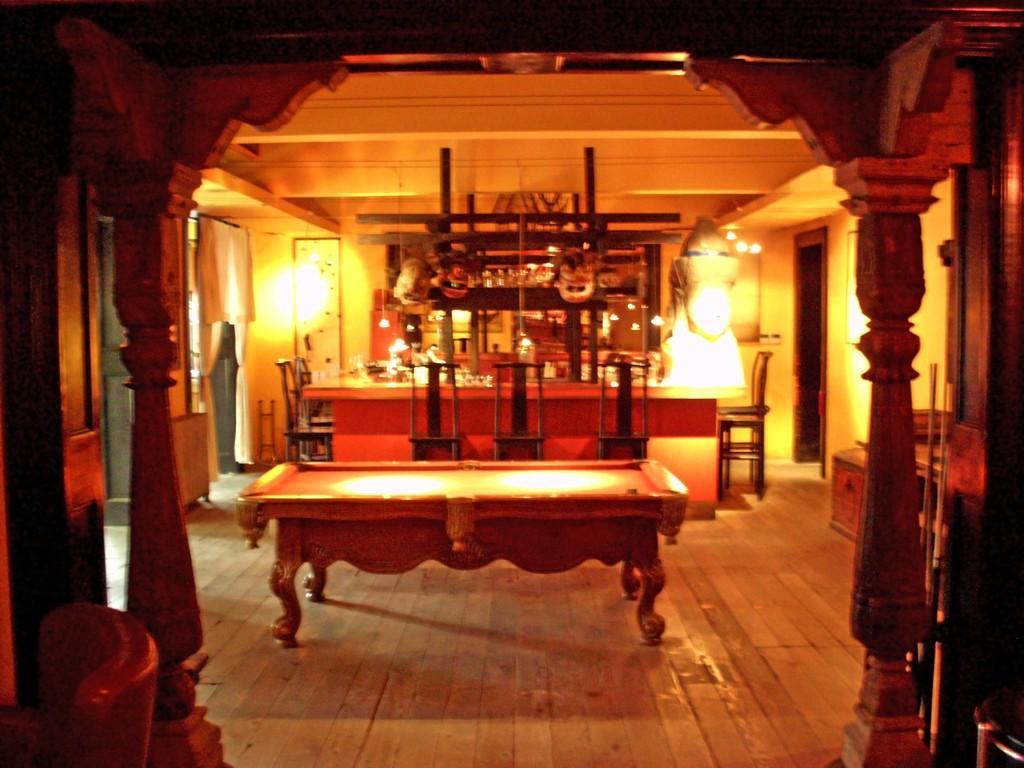Please provide a concise description of this image. Here we can see a room having couple of tables and chairs present and there are lights here and there and we can also see curtains present 